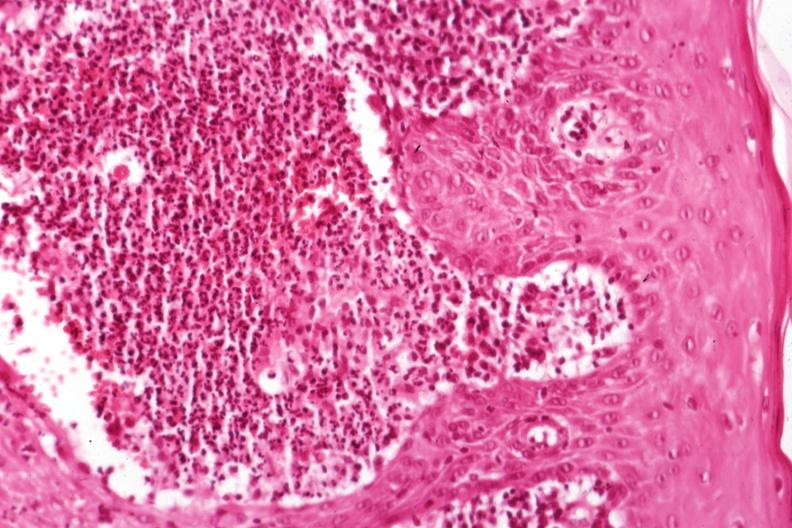s 70yof present?
Answer the question using a single word or phrase. No 